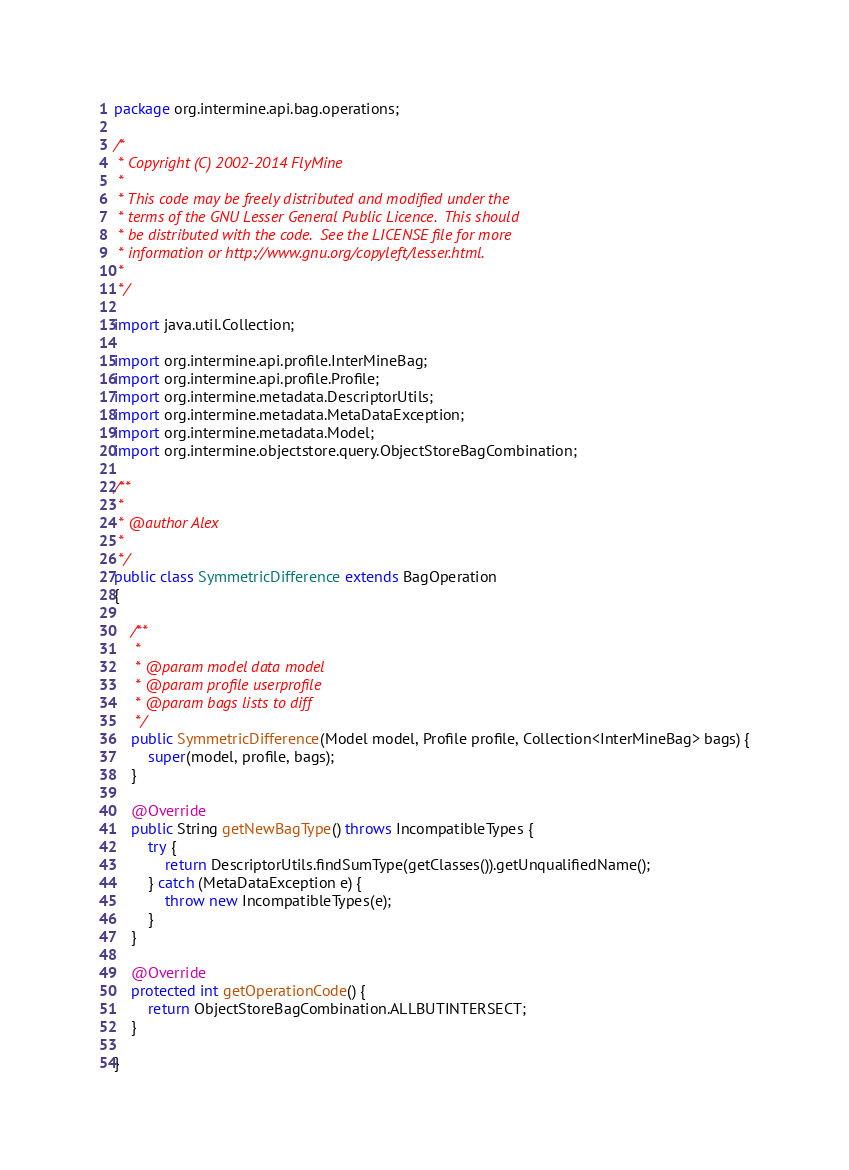Convert code to text. <code><loc_0><loc_0><loc_500><loc_500><_Java_>package org.intermine.api.bag.operations;

/*
 * Copyright (C) 2002-2014 FlyMine
 *
 * This code may be freely distributed and modified under the
 * terms of the GNU Lesser General Public Licence.  This should
 * be distributed with the code.  See the LICENSE file for more
 * information or http://www.gnu.org/copyleft/lesser.html.
 *
 */

import java.util.Collection;

import org.intermine.api.profile.InterMineBag;
import org.intermine.api.profile.Profile;
import org.intermine.metadata.DescriptorUtils;
import org.intermine.metadata.MetaDataException;
import org.intermine.metadata.Model;
import org.intermine.objectstore.query.ObjectStoreBagCombination;

/**
 *
 * @author Alex
 *
 */
public class SymmetricDifference extends BagOperation
{

    /**
     *
     * @param model data model
     * @param profile userprofile
     * @param bags lists to diff
     */
    public SymmetricDifference(Model model, Profile profile, Collection<InterMineBag> bags) {
        super(model, profile, bags);
    }

    @Override
    public String getNewBagType() throws IncompatibleTypes {
        try {
            return DescriptorUtils.findSumType(getClasses()).getUnqualifiedName();
        } catch (MetaDataException e) {
            throw new IncompatibleTypes(e);
        }
    }

    @Override
    protected int getOperationCode() {
        return ObjectStoreBagCombination.ALLBUTINTERSECT;
    }

}
</code> 